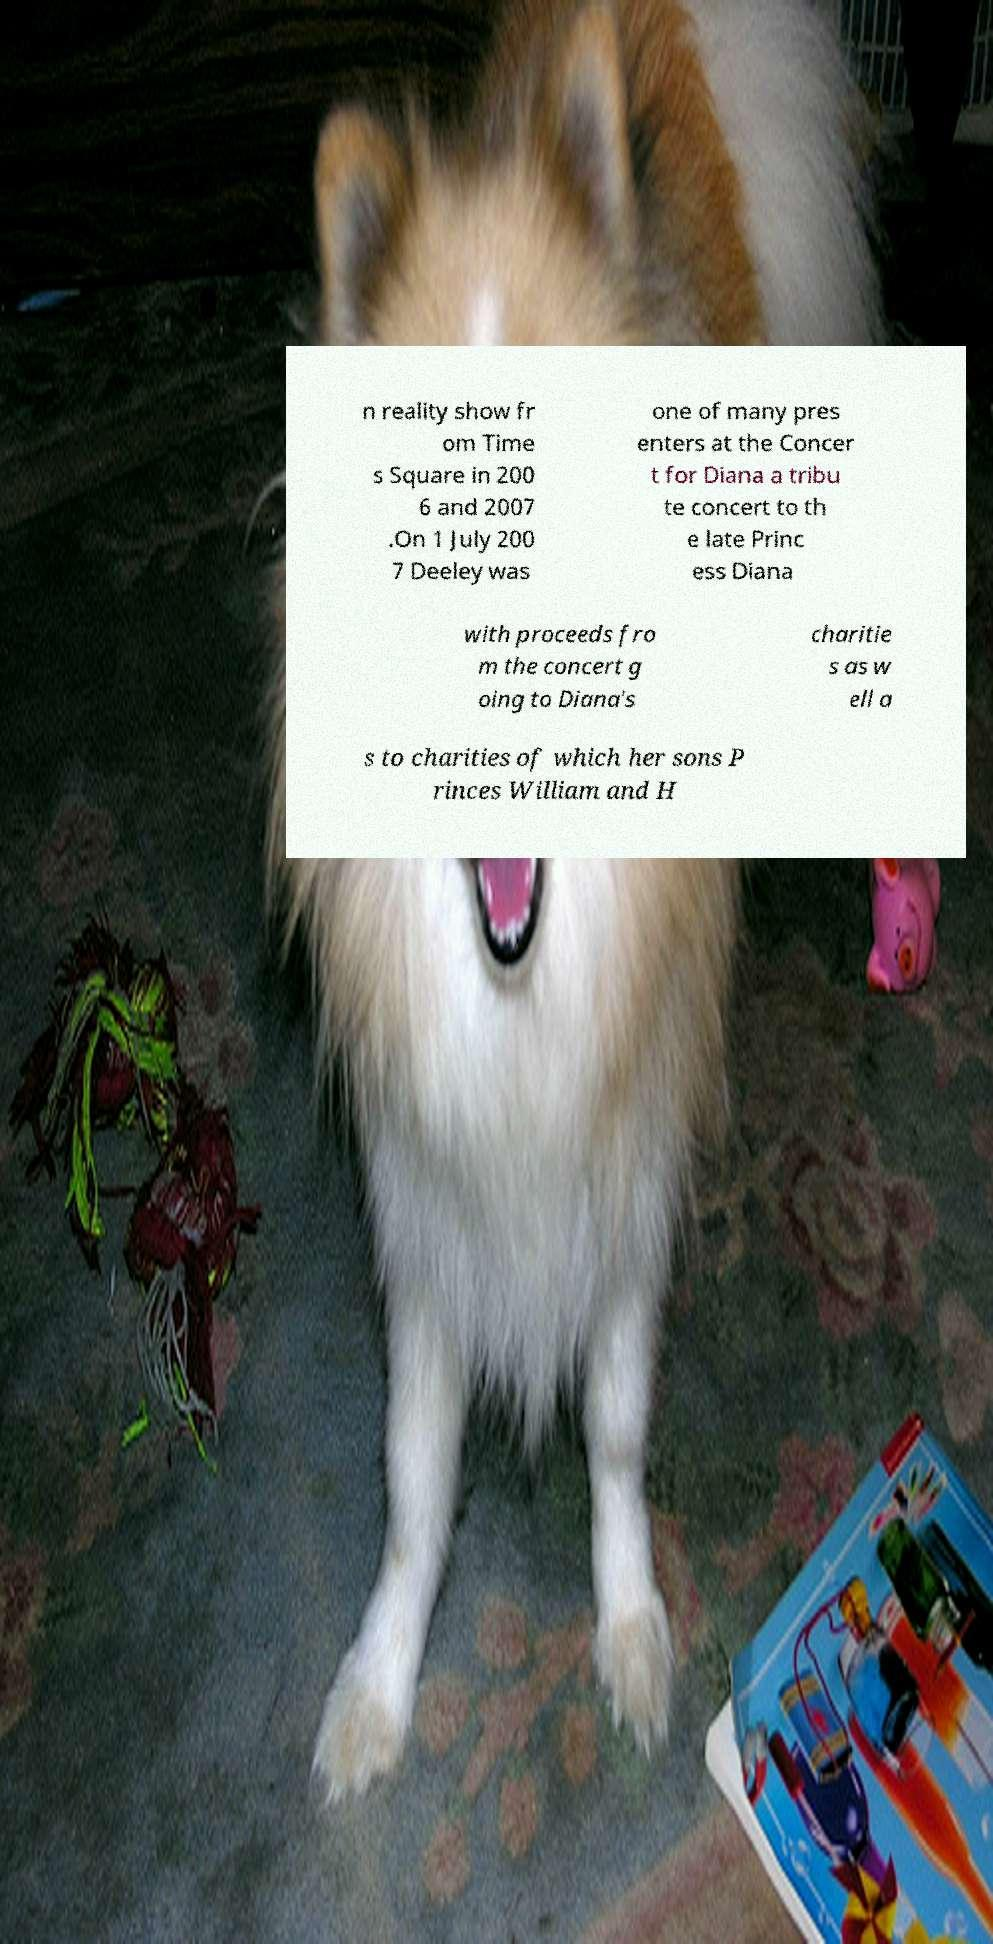Could you assist in decoding the text presented in this image and type it out clearly? n reality show fr om Time s Square in 200 6 and 2007 .On 1 July 200 7 Deeley was one of many pres enters at the Concer t for Diana a tribu te concert to th e late Princ ess Diana with proceeds fro m the concert g oing to Diana's charitie s as w ell a s to charities of which her sons P rinces William and H 